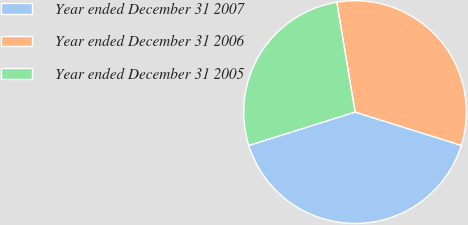Convert chart. <chart><loc_0><loc_0><loc_500><loc_500><pie_chart><fcel>Year ended December 31 2007<fcel>Year ended December 31 2006<fcel>Year ended December 31 2005<nl><fcel>40.34%<fcel>32.45%<fcel>27.21%<nl></chart> 